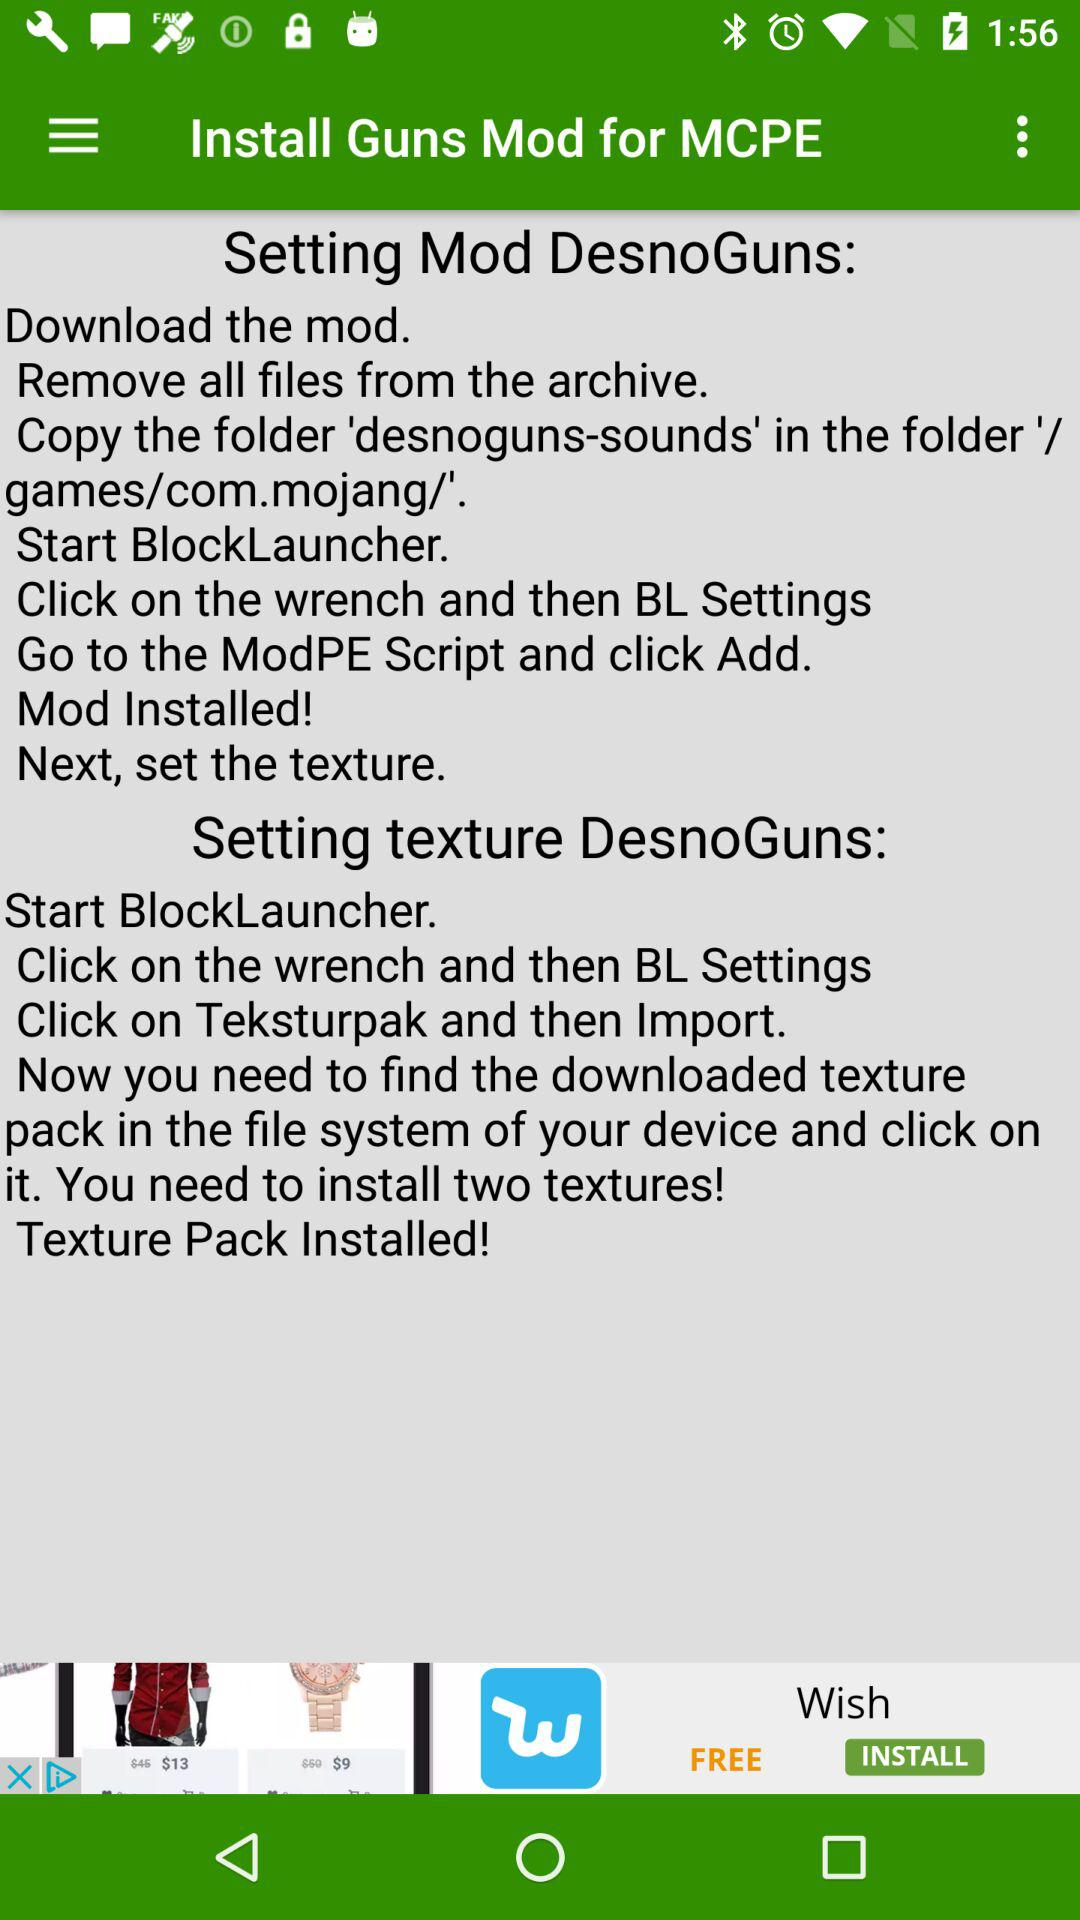How many textures are required to install the mod?
Answer the question using a single word or phrase. 2 